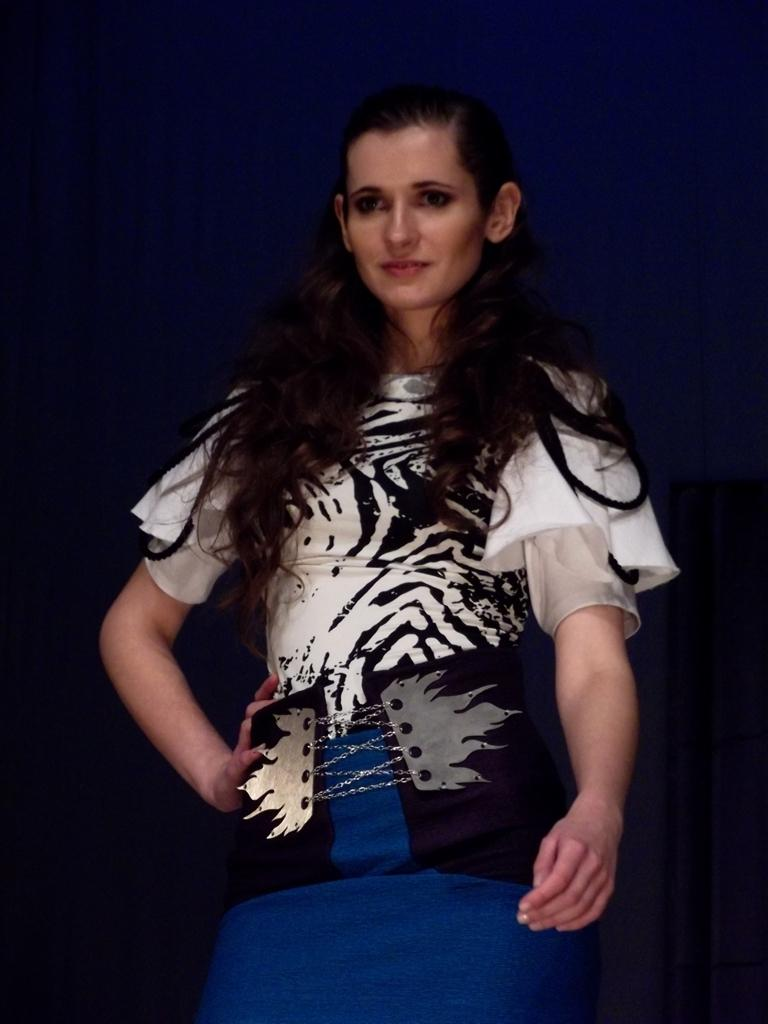Who is present in the image? There is a woman in the image. What can be observed about the background of the image? The background of the image is dark. What is the woman's opinion on the night sky in the image? There is no information about the woman's opinion in the image, nor is there any indication of a night sky present. 